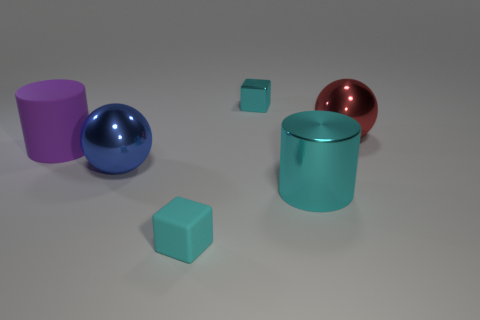Is there a cyan metallic block that has the same size as the cyan metallic cylinder? Upon examining the image, there is no cyan metallic block that is the same size as the cyan metallic cylinder. The cylinder appears to be larger than both of the cubes present in the image. 